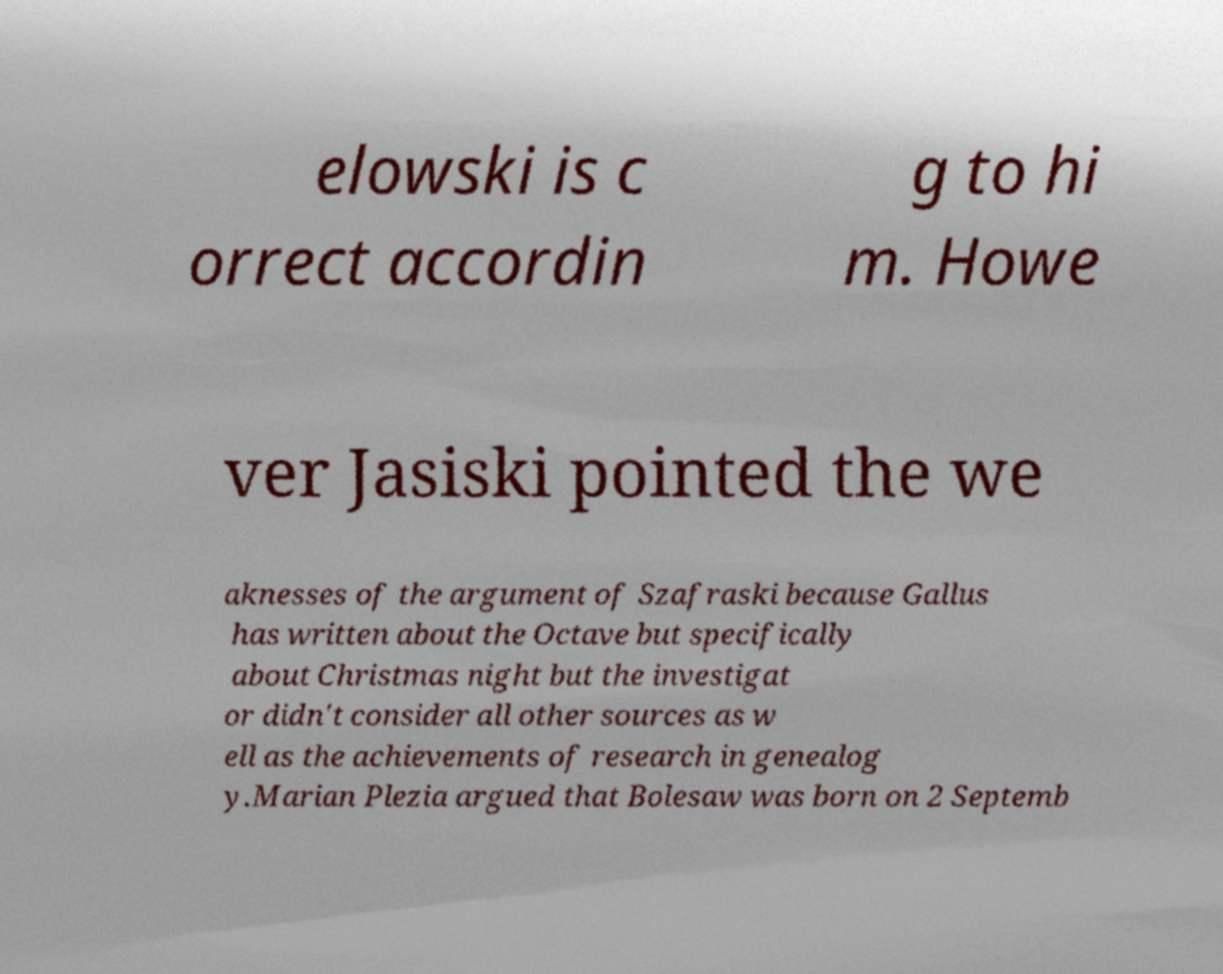Can you accurately transcribe the text from the provided image for me? elowski is c orrect accordin g to hi m. Howe ver Jasiski pointed the we aknesses of the argument of Szafraski because Gallus has written about the Octave but specifically about Christmas night but the investigat or didn't consider all other sources as w ell as the achievements of research in genealog y.Marian Plezia argued that Bolesaw was born on 2 Septemb 